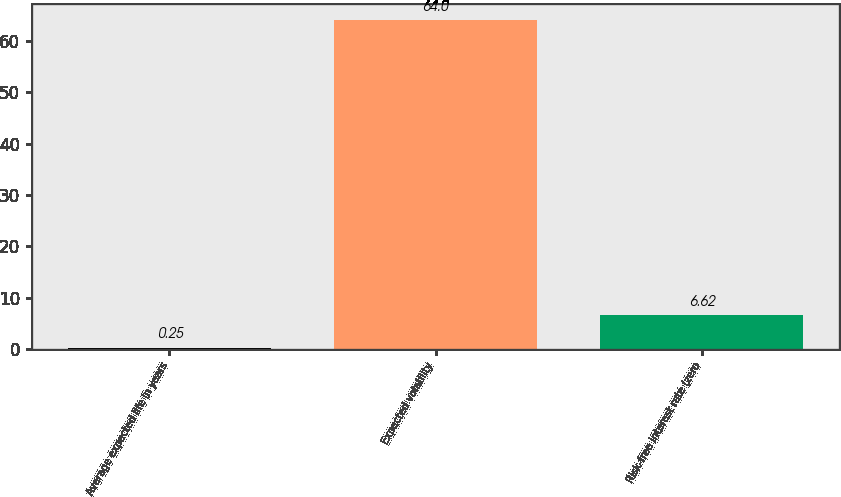<chart> <loc_0><loc_0><loc_500><loc_500><bar_chart><fcel>Average expected life in years<fcel>Expected volatility<fcel>Risk-free interest rate (zero<nl><fcel>0.25<fcel>64<fcel>6.62<nl></chart> 